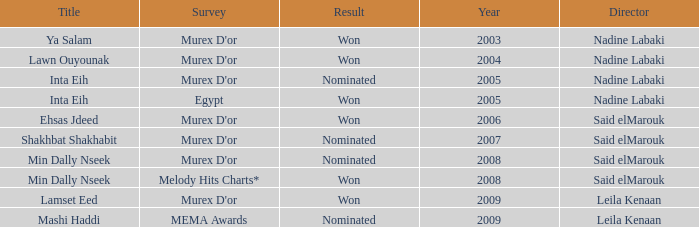What survey has the Ehsas Jdeed title? Murex D'or. 